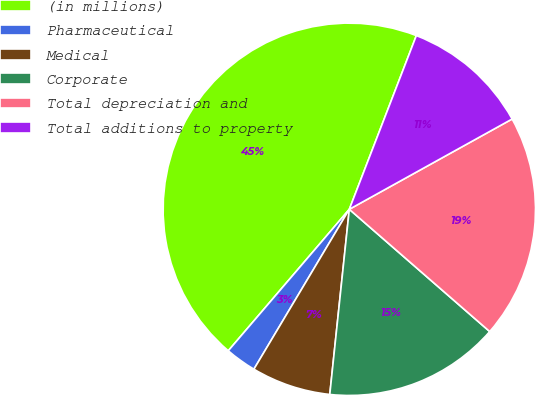<chart> <loc_0><loc_0><loc_500><loc_500><pie_chart><fcel>(in millions)<fcel>Pharmaceutical<fcel>Medical<fcel>Corporate<fcel>Total depreciation and<fcel>Total additions to property<nl><fcel>44.6%<fcel>2.7%<fcel>6.89%<fcel>15.27%<fcel>19.46%<fcel>11.08%<nl></chart> 